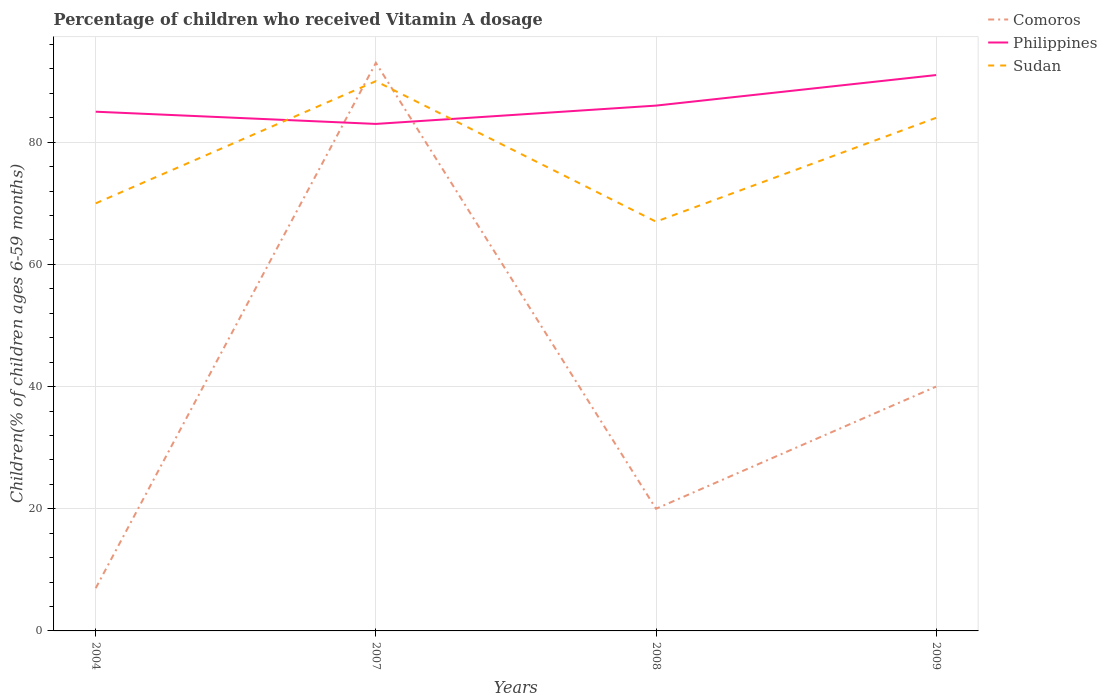How many different coloured lines are there?
Ensure brevity in your answer.  3. Is the number of lines equal to the number of legend labels?
Your answer should be very brief. Yes. Across all years, what is the maximum percentage of children who received Vitamin A dosage in Philippines?
Keep it short and to the point. 83. In which year was the percentage of children who received Vitamin A dosage in Comoros maximum?
Offer a very short reply. 2004. Is the percentage of children who received Vitamin A dosage in Philippines strictly greater than the percentage of children who received Vitamin A dosage in Sudan over the years?
Provide a short and direct response. No. Are the values on the major ticks of Y-axis written in scientific E-notation?
Offer a terse response. No. Does the graph contain any zero values?
Your answer should be very brief. No. What is the title of the graph?
Ensure brevity in your answer.  Percentage of children who received Vitamin A dosage. What is the label or title of the Y-axis?
Provide a succinct answer. Children(% of children ages 6-59 months). What is the Children(% of children ages 6-59 months) in Comoros in 2004?
Your response must be concise. 7. What is the Children(% of children ages 6-59 months) in Sudan in 2004?
Your response must be concise. 70. What is the Children(% of children ages 6-59 months) of Comoros in 2007?
Your response must be concise. 93. What is the Children(% of children ages 6-59 months) in Philippines in 2007?
Your answer should be compact. 83. What is the Children(% of children ages 6-59 months) of Philippines in 2008?
Make the answer very short. 86. What is the Children(% of children ages 6-59 months) of Sudan in 2008?
Give a very brief answer. 67. What is the Children(% of children ages 6-59 months) of Philippines in 2009?
Make the answer very short. 91. What is the Children(% of children ages 6-59 months) of Sudan in 2009?
Keep it short and to the point. 84. Across all years, what is the maximum Children(% of children ages 6-59 months) of Comoros?
Offer a terse response. 93. Across all years, what is the maximum Children(% of children ages 6-59 months) in Philippines?
Ensure brevity in your answer.  91. Across all years, what is the maximum Children(% of children ages 6-59 months) of Sudan?
Offer a terse response. 90. Across all years, what is the minimum Children(% of children ages 6-59 months) in Comoros?
Provide a short and direct response. 7. Across all years, what is the minimum Children(% of children ages 6-59 months) in Sudan?
Ensure brevity in your answer.  67. What is the total Children(% of children ages 6-59 months) of Comoros in the graph?
Your answer should be very brief. 160. What is the total Children(% of children ages 6-59 months) in Philippines in the graph?
Provide a short and direct response. 345. What is the total Children(% of children ages 6-59 months) of Sudan in the graph?
Provide a short and direct response. 311. What is the difference between the Children(% of children ages 6-59 months) in Comoros in 2004 and that in 2007?
Give a very brief answer. -86. What is the difference between the Children(% of children ages 6-59 months) in Sudan in 2004 and that in 2007?
Ensure brevity in your answer.  -20. What is the difference between the Children(% of children ages 6-59 months) of Philippines in 2004 and that in 2008?
Provide a succinct answer. -1. What is the difference between the Children(% of children ages 6-59 months) of Comoros in 2004 and that in 2009?
Offer a terse response. -33. What is the difference between the Children(% of children ages 6-59 months) of Sudan in 2004 and that in 2009?
Offer a terse response. -14. What is the difference between the Children(% of children ages 6-59 months) of Comoros in 2007 and that in 2008?
Offer a terse response. 73. What is the difference between the Children(% of children ages 6-59 months) in Philippines in 2007 and that in 2008?
Make the answer very short. -3. What is the difference between the Children(% of children ages 6-59 months) of Comoros in 2007 and that in 2009?
Ensure brevity in your answer.  53. What is the difference between the Children(% of children ages 6-59 months) of Sudan in 2007 and that in 2009?
Provide a short and direct response. 6. What is the difference between the Children(% of children ages 6-59 months) of Philippines in 2008 and that in 2009?
Offer a very short reply. -5. What is the difference between the Children(% of children ages 6-59 months) of Sudan in 2008 and that in 2009?
Offer a very short reply. -17. What is the difference between the Children(% of children ages 6-59 months) in Comoros in 2004 and the Children(% of children ages 6-59 months) in Philippines in 2007?
Make the answer very short. -76. What is the difference between the Children(% of children ages 6-59 months) of Comoros in 2004 and the Children(% of children ages 6-59 months) of Sudan in 2007?
Your response must be concise. -83. What is the difference between the Children(% of children ages 6-59 months) in Philippines in 2004 and the Children(% of children ages 6-59 months) in Sudan in 2007?
Your answer should be compact. -5. What is the difference between the Children(% of children ages 6-59 months) of Comoros in 2004 and the Children(% of children ages 6-59 months) of Philippines in 2008?
Your answer should be very brief. -79. What is the difference between the Children(% of children ages 6-59 months) of Comoros in 2004 and the Children(% of children ages 6-59 months) of Sudan in 2008?
Your response must be concise. -60. What is the difference between the Children(% of children ages 6-59 months) of Comoros in 2004 and the Children(% of children ages 6-59 months) of Philippines in 2009?
Give a very brief answer. -84. What is the difference between the Children(% of children ages 6-59 months) in Comoros in 2004 and the Children(% of children ages 6-59 months) in Sudan in 2009?
Provide a short and direct response. -77. What is the difference between the Children(% of children ages 6-59 months) in Comoros in 2007 and the Children(% of children ages 6-59 months) in Sudan in 2009?
Ensure brevity in your answer.  9. What is the difference between the Children(% of children ages 6-59 months) in Comoros in 2008 and the Children(% of children ages 6-59 months) in Philippines in 2009?
Your response must be concise. -71. What is the difference between the Children(% of children ages 6-59 months) in Comoros in 2008 and the Children(% of children ages 6-59 months) in Sudan in 2009?
Offer a very short reply. -64. What is the difference between the Children(% of children ages 6-59 months) of Philippines in 2008 and the Children(% of children ages 6-59 months) of Sudan in 2009?
Ensure brevity in your answer.  2. What is the average Children(% of children ages 6-59 months) in Philippines per year?
Ensure brevity in your answer.  86.25. What is the average Children(% of children ages 6-59 months) in Sudan per year?
Provide a short and direct response. 77.75. In the year 2004, what is the difference between the Children(% of children ages 6-59 months) in Comoros and Children(% of children ages 6-59 months) in Philippines?
Ensure brevity in your answer.  -78. In the year 2004, what is the difference between the Children(% of children ages 6-59 months) of Comoros and Children(% of children ages 6-59 months) of Sudan?
Provide a succinct answer. -63. In the year 2007, what is the difference between the Children(% of children ages 6-59 months) in Philippines and Children(% of children ages 6-59 months) in Sudan?
Provide a short and direct response. -7. In the year 2008, what is the difference between the Children(% of children ages 6-59 months) of Comoros and Children(% of children ages 6-59 months) of Philippines?
Your answer should be compact. -66. In the year 2008, what is the difference between the Children(% of children ages 6-59 months) of Comoros and Children(% of children ages 6-59 months) of Sudan?
Your response must be concise. -47. In the year 2008, what is the difference between the Children(% of children ages 6-59 months) in Philippines and Children(% of children ages 6-59 months) in Sudan?
Offer a very short reply. 19. In the year 2009, what is the difference between the Children(% of children ages 6-59 months) of Comoros and Children(% of children ages 6-59 months) of Philippines?
Offer a terse response. -51. In the year 2009, what is the difference between the Children(% of children ages 6-59 months) in Comoros and Children(% of children ages 6-59 months) in Sudan?
Your answer should be compact. -44. In the year 2009, what is the difference between the Children(% of children ages 6-59 months) of Philippines and Children(% of children ages 6-59 months) of Sudan?
Your answer should be compact. 7. What is the ratio of the Children(% of children ages 6-59 months) in Comoros in 2004 to that in 2007?
Ensure brevity in your answer.  0.08. What is the ratio of the Children(% of children ages 6-59 months) in Philippines in 2004 to that in 2007?
Provide a short and direct response. 1.02. What is the ratio of the Children(% of children ages 6-59 months) of Sudan in 2004 to that in 2007?
Provide a short and direct response. 0.78. What is the ratio of the Children(% of children ages 6-59 months) in Philippines in 2004 to that in 2008?
Make the answer very short. 0.99. What is the ratio of the Children(% of children ages 6-59 months) of Sudan in 2004 to that in 2008?
Give a very brief answer. 1.04. What is the ratio of the Children(% of children ages 6-59 months) in Comoros in 2004 to that in 2009?
Make the answer very short. 0.17. What is the ratio of the Children(% of children ages 6-59 months) in Philippines in 2004 to that in 2009?
Keep it short and to the point. 0.93. What is the ratio of the Children(% of children ages 6-59 months) in Sudan in 2004 to that in 2009?
Offer a very short reply. 0.83. What is the ratio of the Children(% of children ages 6-59 months) of Comoros in 2007 to that in 2008?
Make the answer very short. 4.65. What is the ratio of the Children(% of children ages 6-59 months) in Philippines in 2007 to that in 2008?
Offer a terse response. 0.97. What is the ratio of the Children(% of children ages 6-59 months) of Sudan in 2007 to that in 2008?
Make the answer very short. 1.34. What is the ratio of the Children(% of children ages 6-59 months) in Comoros in 2007 to that in 2009?
Provide a short and direct response. 2.33. What is the ratio of the Children(% of children ages 6-59 months) in Philippines in 2007 to that in 2009?
Offer a very short reply. 0.91. What is the ratio of the Children(% of children ages 6-59 months) of Sudan in 2007 to that in 2009?
Give a very brief answer. 1.07. What is the ratio of the Children(% of children ages 6-59 months) of Philippines in 2008 to that in 2009?
Offer a terse response. 0.95. What is the ratio of the Children(% of children ages 6-59 months) in Sudan in 2008 to that in 2009?
Ensure brevity in your answer.  0.8. What is the difference between the highest and the second highest Children(% of children ages 6-59 months) of Sudan?
Your answer should be compact. 6. 